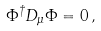Convert formula to latex. <formula><loc_0><loc_0><loc_500><loc_500>\Phi ^ { \dagger } D _ { \mu } \Phi = 0 \, ,</formula> 